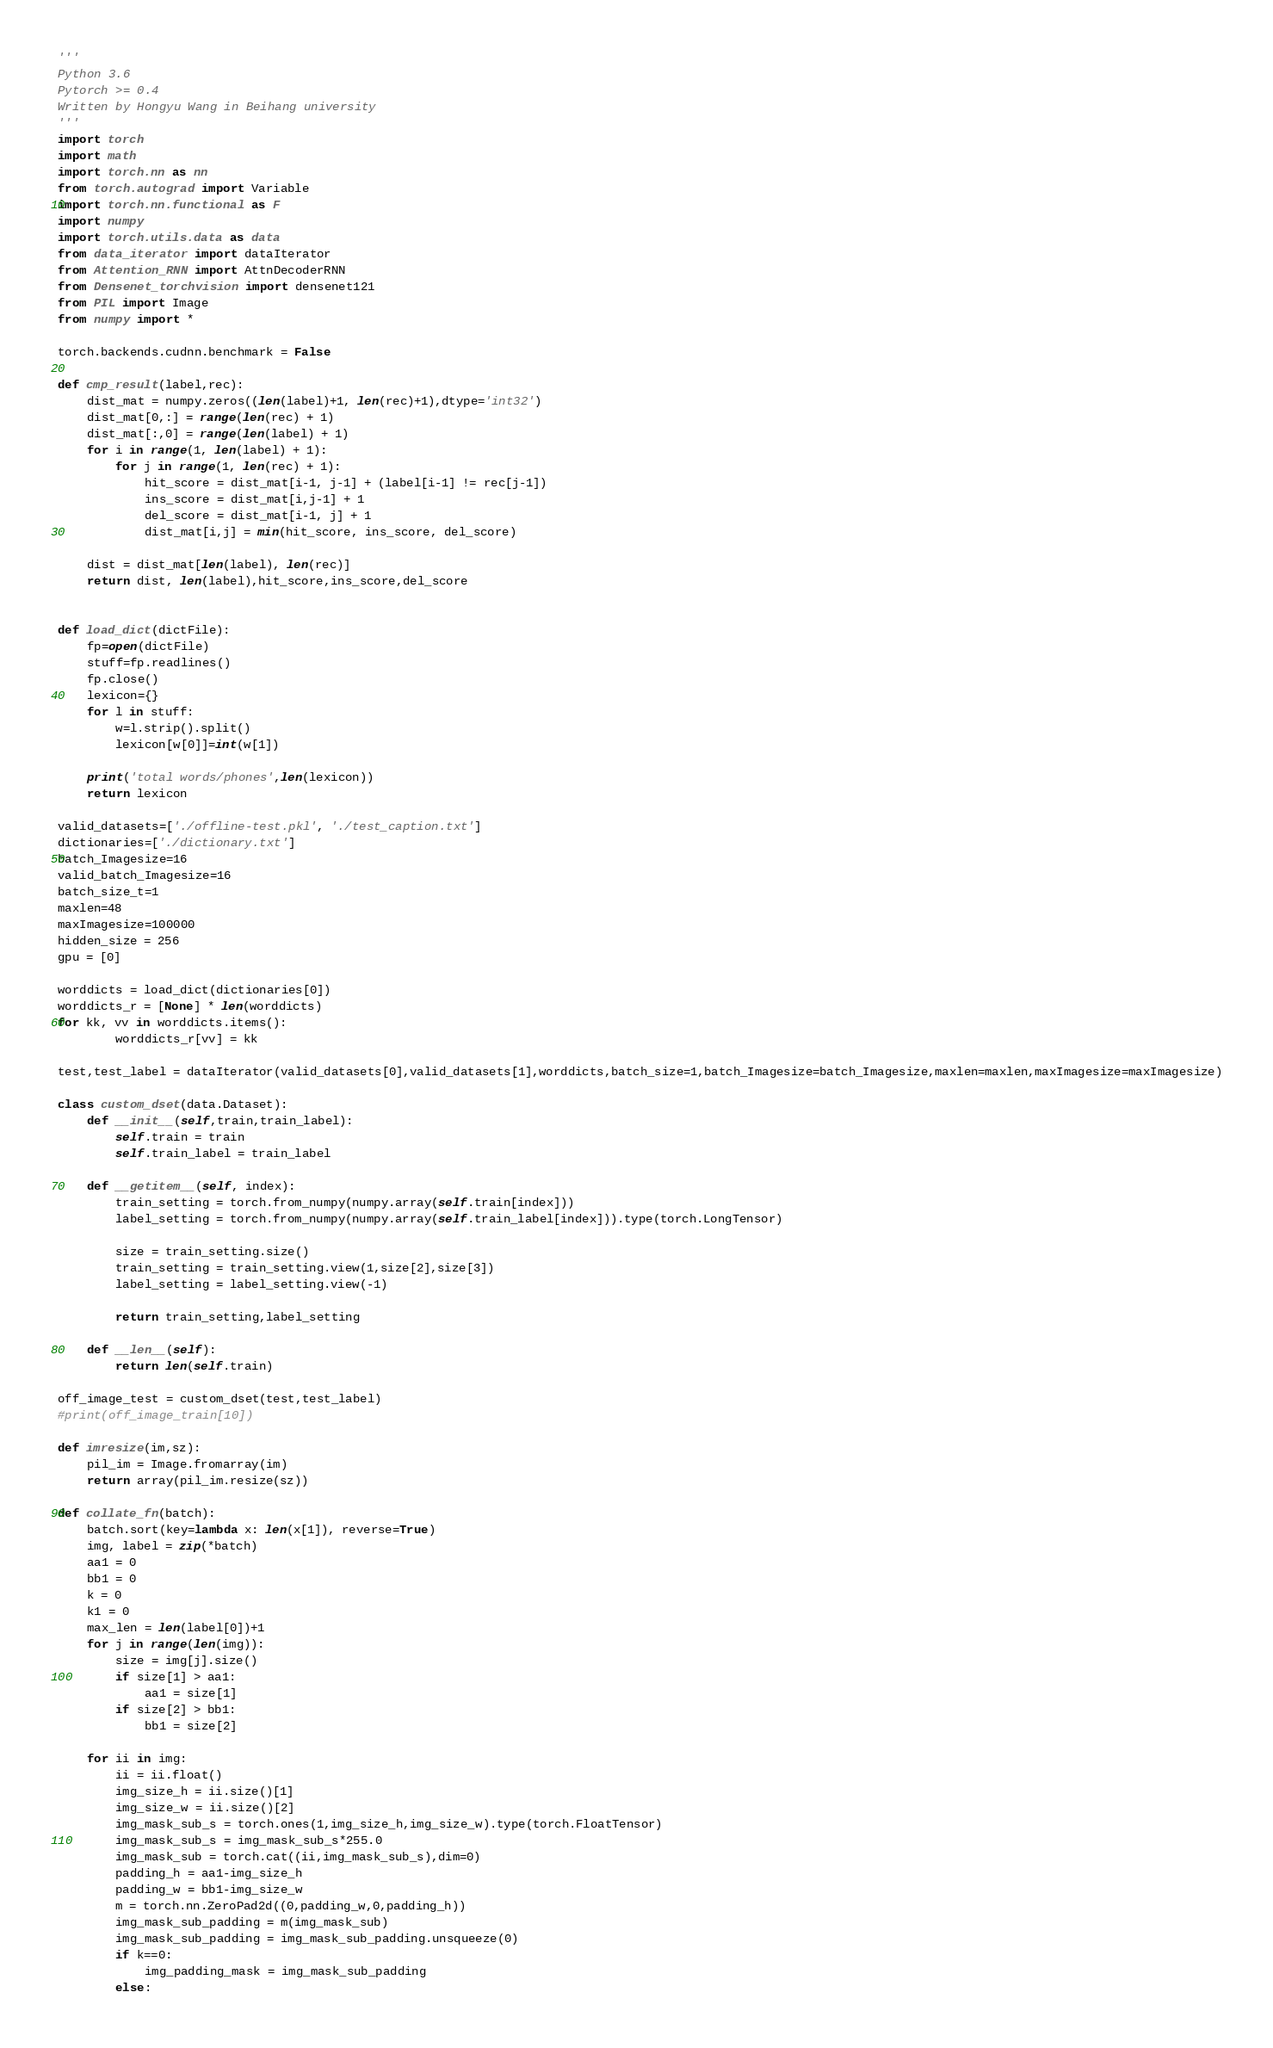<code> <loc_0><loc_0><loc_500><loc_500><_Python_>'''
Python 3.6 
Pytorch >= 0.4
Written by Hongyu Wang in Beihang university
'''
import torch
import math
import torch.nn as nn
from torch.autograd import Variable
import torch.nn.functional as F
import numpy
import torch.utils.data as data
from data_iterator import dataIterator
from Attention_RNN import AttnDecoderRNN
from Densenet_torchvision import densenet121
from PIL import Image
from numpy import *

torch.backends.cudnn.benchmark = False

def cmp_result(label,rec):
    dist_mat = numpy.zeros((len(label)+1, len(rec)+1),dtype='int32')
    dist_mat[0,:] = range(len(rec) + 1)
    dist_mat[:,0] = range(len(label) + 1)
    for i in range(1, len(label) + 1):
        for j in range(1, len(rec) + 1):
            hit_score = dist_mat[i-1, j-1] + (label[i-1] != rec[j-1])
            ins_score = dist_mat[i,j-1] + 1
            del_score = dist_mat[i-1, j] + 1
            dist_mat[i,j] = min(hit_score, ins_score, del_score)

    dist = dist_mat[len(label), len(rec)]
    return dist, len(label),hit_score,ins_score,del_score


def load_dict(dictFile):
    fp=open(dictFile)
    stuff=fp.readlines()
    fp.close()
    lexicon={}
    for l in stuff:
        w=l.strip().split()
        lexicon[w[0]]=int(w[1])

    print('total words/phones',len(lexicon))
    return lexicon

valid_datasets=['./offline-test.pkl', './test_caption.txt']
dictionaries=['./dictionary.txt']
batch_Imagesize=16
valid_batch_Imagesize=16
batch_size_t=1
maxlen=48
maxImagesize=100000
hidden_size = 256
gpu = [0]

worddicts = load_dict(dictionaries[0])
worddicts_r = [None] * len(worddicts)
for kk, vv in worddicts.items():
        worddicts_r[vv] = kk

test,test_label = dataIterator(valid_datasets[0],valid_datasets[1],worddicts,batch_size=1,batch_Imagesize=batch_Imagesize,maxlen=maxlen,maxImagesize=maxImagesize)

class custom_dset(data.Dataset):
    def __init__(self,train,train_label):
        self.train = train
        self.train_label = train_label

    def __getitem__(self, index):
        train_setting = torch.from_numpy(numpy.array(self.train[index]))
        label_setting = torch.from_numpy(numpy.array(self.train_label[index])).type(torch.LongTensor)

        size = train_setting.size()
        train_setting = train_setting.view(1,size[2],size[3])
        label_setting = label_setting.view(-1)

        return train_setting,label_setting

    def __len__(self):
        return len(self.train)

off_image_test = custom_dset(test,test_label)
#print(off_image_train[10])

def imresize(im,sz):
    pil_im = Image.fromarray(im)
    return array(pil_im.resize(sz))

def collate_fn(batch):
    batch.sort(key=lambda x: len(x[1]), reverse=True)
    img, label = zip(*batch)
    aa1 = 0
    bb1 = 0
    k = 0
    k1 = 0
    max_len = len(label[0])+1
    for j in range(len(img)):
        size = img[j].size()
        if size[1] > aa1:
            aa1 = size[1]
        if size[2] > bb1:
            bb1 = size[2]

    for ii in img:
        ii = ii.float()
        img_size_h = ii.size()[1]
        img_size_w = ii.size()[2]
        img_mask_sub_s = torch.ones(1,img_size_h,img_size_w).type(torch.FloatTensor)
        img_mask_sub_s = img_mask_sub_s*255.0
        img_mask_sub = torch.cat((ii,img_mask_sub_s),dim=0)
        padding_h = aa1-img_size_h
        padding_w = bb1-img_size_w
        m = torch.nn.ZeroPad2d((0,padding_w,0,padding_h))
        img_mask_sub_padding = m(img_mask_sub)
        img_mask_sub_padding = img_mask_sub_padding.unsqueeze(0)
        if k==0:
            img_padding_mask = img_mask_sub_padding
        else:</code> 